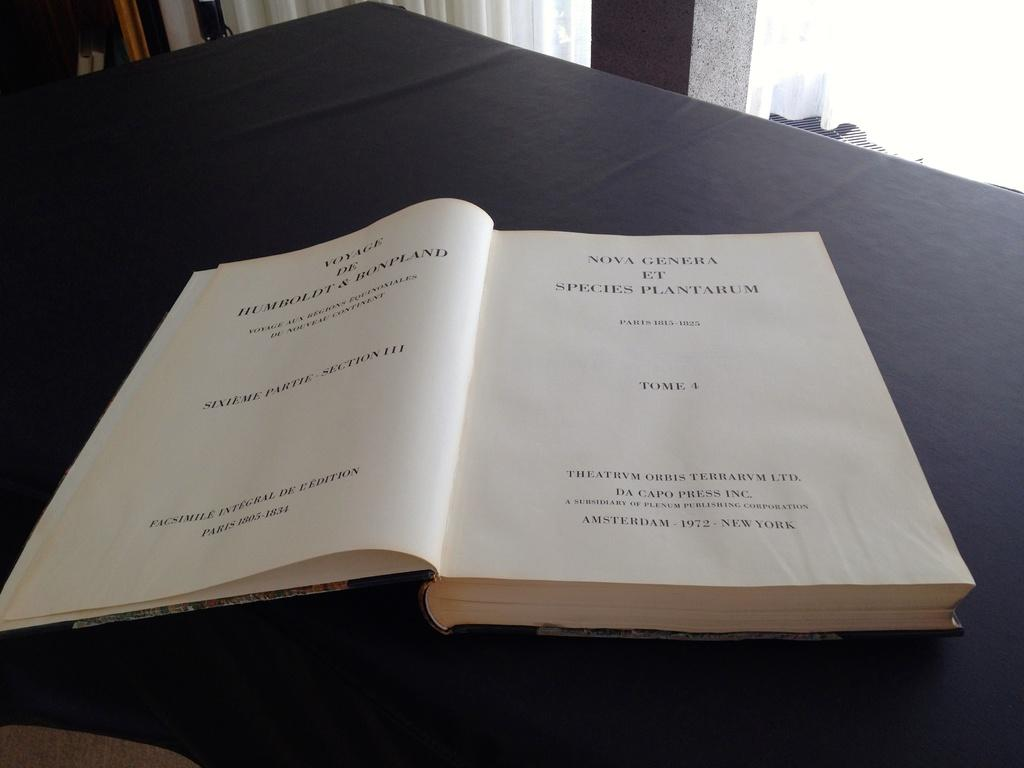<image>
Give a short and clear explanation of the subsequent image. The book is turned to the page starting with the word Voyage. 